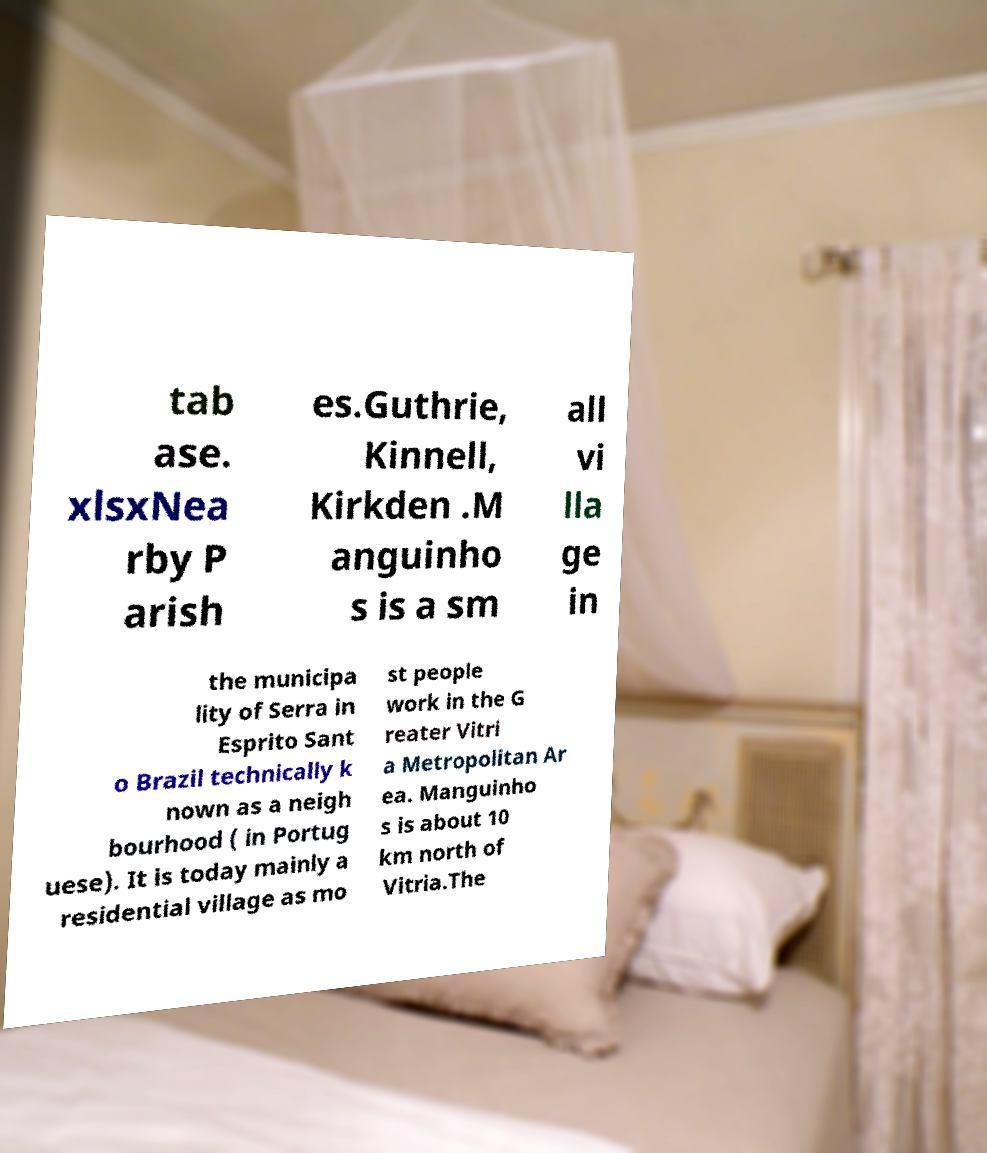Can you read and provide the text displayed in the image?This photo seems to have some interesting text. Can you extract and type it out for me? tab ase. xlsxNea rby P arish es.Guthrie, Kinnell, Kirkden .M anguinho s is a sm all vi lla ge in the municipa lity of Serra in Esprito Sant o Brazil technically k nown as a neigh bourhood ( in Portug uese). It is today mainly a residential village as mo st people work in the G reater Vitri a Metropolitan Ar ea. Manguinho s is about 10 km north of Vitria.The 